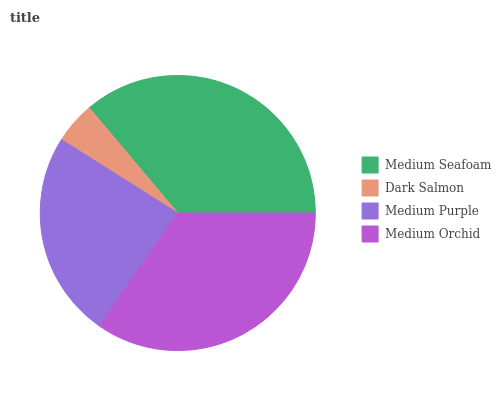Is Dark Salmon the minimum?
Answer yes or no. Yes. Is Medium Seafoam the maximum?
Answer yes or no. Yes. Is Medium Purple the minimum?
Answer yes or no. No. Is Medium Purple the maximum?
Answer yes or no. No. Is Medium Purple greater than Dark Salmon?
Answer yes or no. Yes. Is Dark Salmon less than Medium Purple?
Answer yes or no. Yes. Is Dark Salmon greater than Medium Purple?
Answer yes or no. No. Is Medium Purple less than Dark Salmon?
Answer yes or no. No. Is Medium Orchid the high median?
Answer yes or no. Yes. Is Medium Purple the low median?
Answer yes or no. Yes. Is Medium Purple the high median?
Answer yes or no. No. Is Dark Salmon the low median?
Answer yes or no. No. 